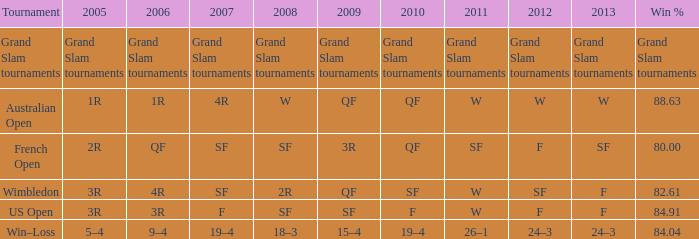What item in 2007 is linked to science fiction in 2008 and fantasy in 2010? F. 